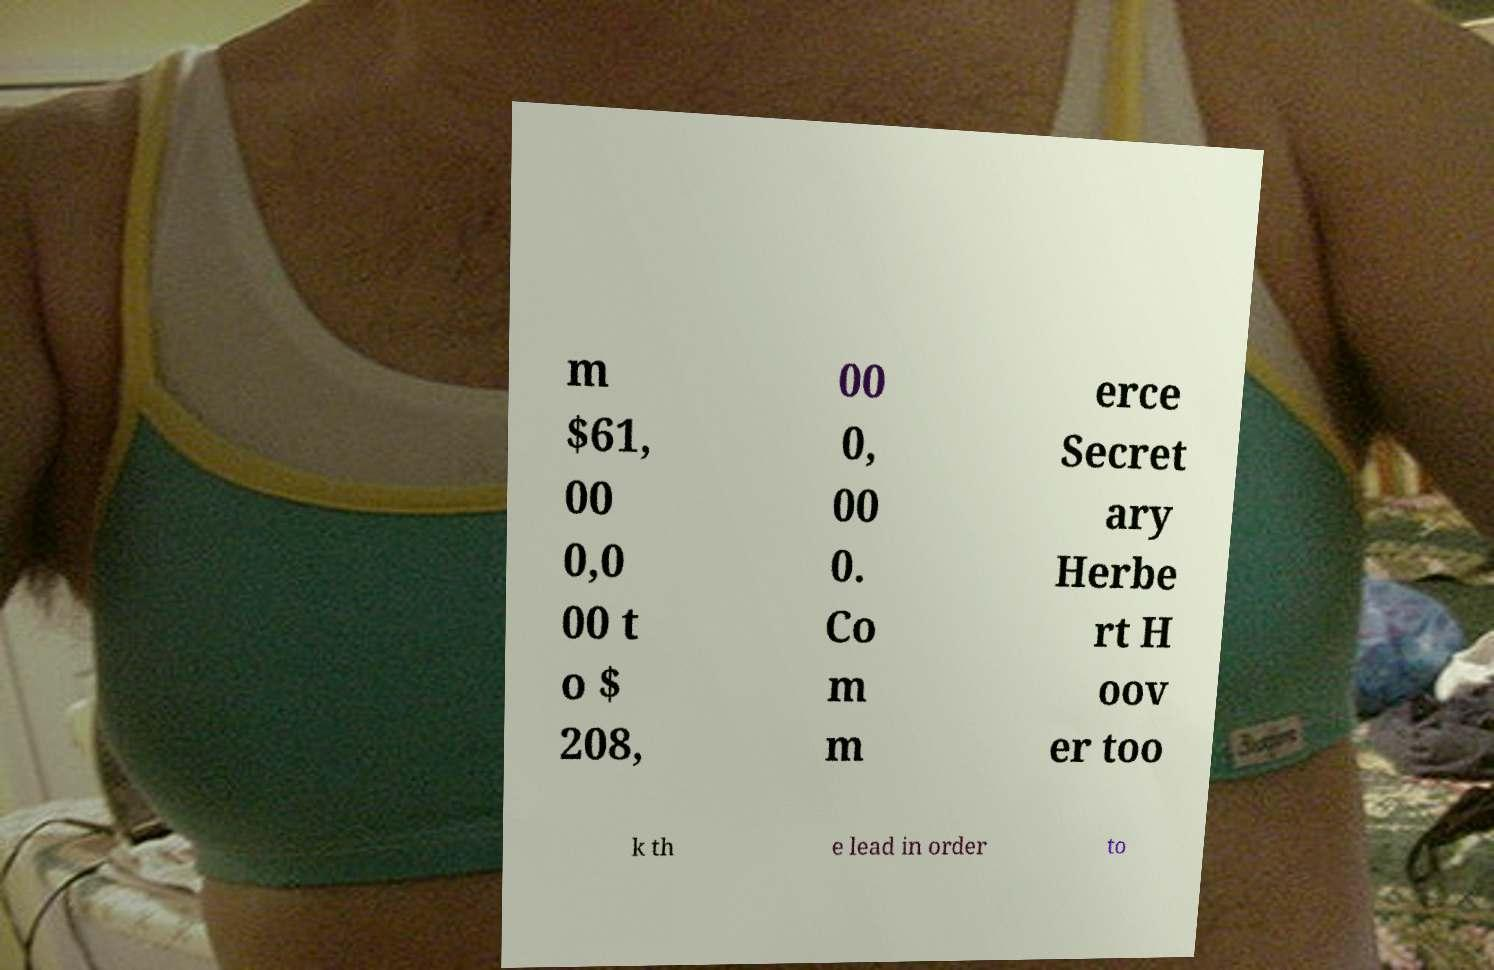There's text embedded in this image that I need extracted. Can you transcribe it verbatim? m $61, 00 0,0 00 t o $ 208, 00 0, 00 0. Co m m erce Secret ary Herbe rt H oov er too k th e lead in order to 